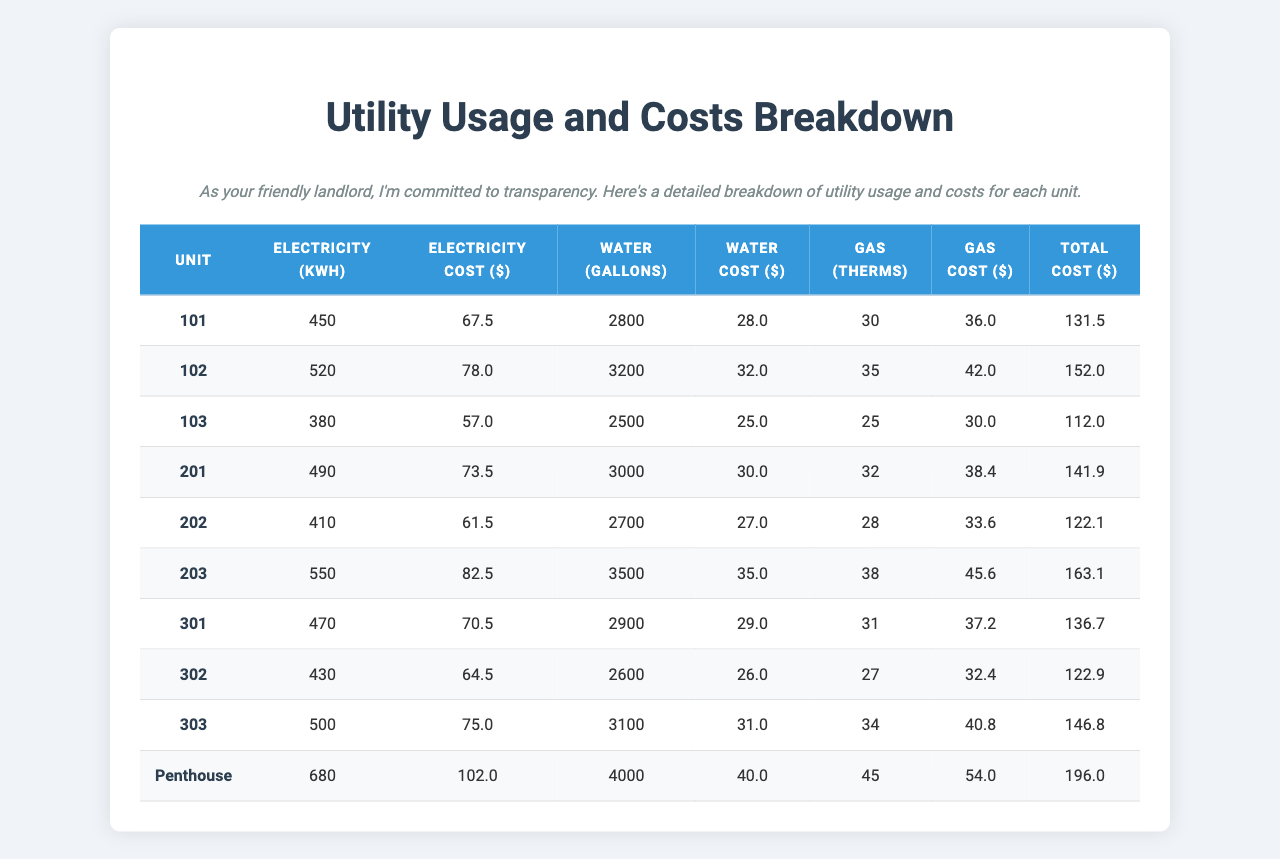What is the electricity cost for unit 102? The table lists the electricity cost for each unit, where "Unit 102" has a cost of $78.00.
Answer: $78.00 Which unit has the highest total cost? By examining the total cost column, "Penthouse" has a total cost of $196.00, which is the highest among all units.
Answer: Penthouse What is the average water cost across all units? To find the average water cost, first, sum the water costs: 28 + 32 + 25 + 30 + 27 + 35 + 29 + 26 + 31 + 40 =  302. Then divide by the number of units (10): 302 / 10 = $30.20.
Answer: $30.20 Is the gas cost for unit 201 higher than that for unit 202? For unit 201, the gas cost is $38.40, and for unit 202, it is $33.60. Since $38.40 > $33.60, the statement is true.
Answer: Yes What is the total electricity usage for all units combined? Adding up the electricity usage: 450 + 520 + 380 + 490 + 410 + 550 + 470 + 430 + 500 + 680 = 4,080 kWh.
Answer: 4,080 kWh Which unit uses the least amount of electricity? The table shows that unit 103 has the lowest electricity usage at 380 kWh.
Answer: 103 What is the total cost for all units combined? The total costs are summed up: 131.50 + 152.00 + 112.00 + 141.90 + 122.10 + 163.10 + 136.70 + 122.90 + 146.80 + 196.00 = $1,096.10.
Answer: $1,096.10 How much more does unit 203 spend on gas compared to unit 101? Unit 203 spends $45.60 on gas, while unit 101 spends $36.00. The difference is $45.60 - $36.00 = $9.60.
Answer: $9.60 What percentage of the total cost does unit 102 represent? The total cost for all units is $1,096.10. Unit 102 has a total cost of $152.00. The percentage is (152.00 / 1,096.10) * 100 = 13.87%.
Answer: 13.87% Which unit consumes 680 kWh of electricity? Referring to the electricity usage column, the "Penthouse" unit consumes 680 kWh.
Answer: Penthouse 